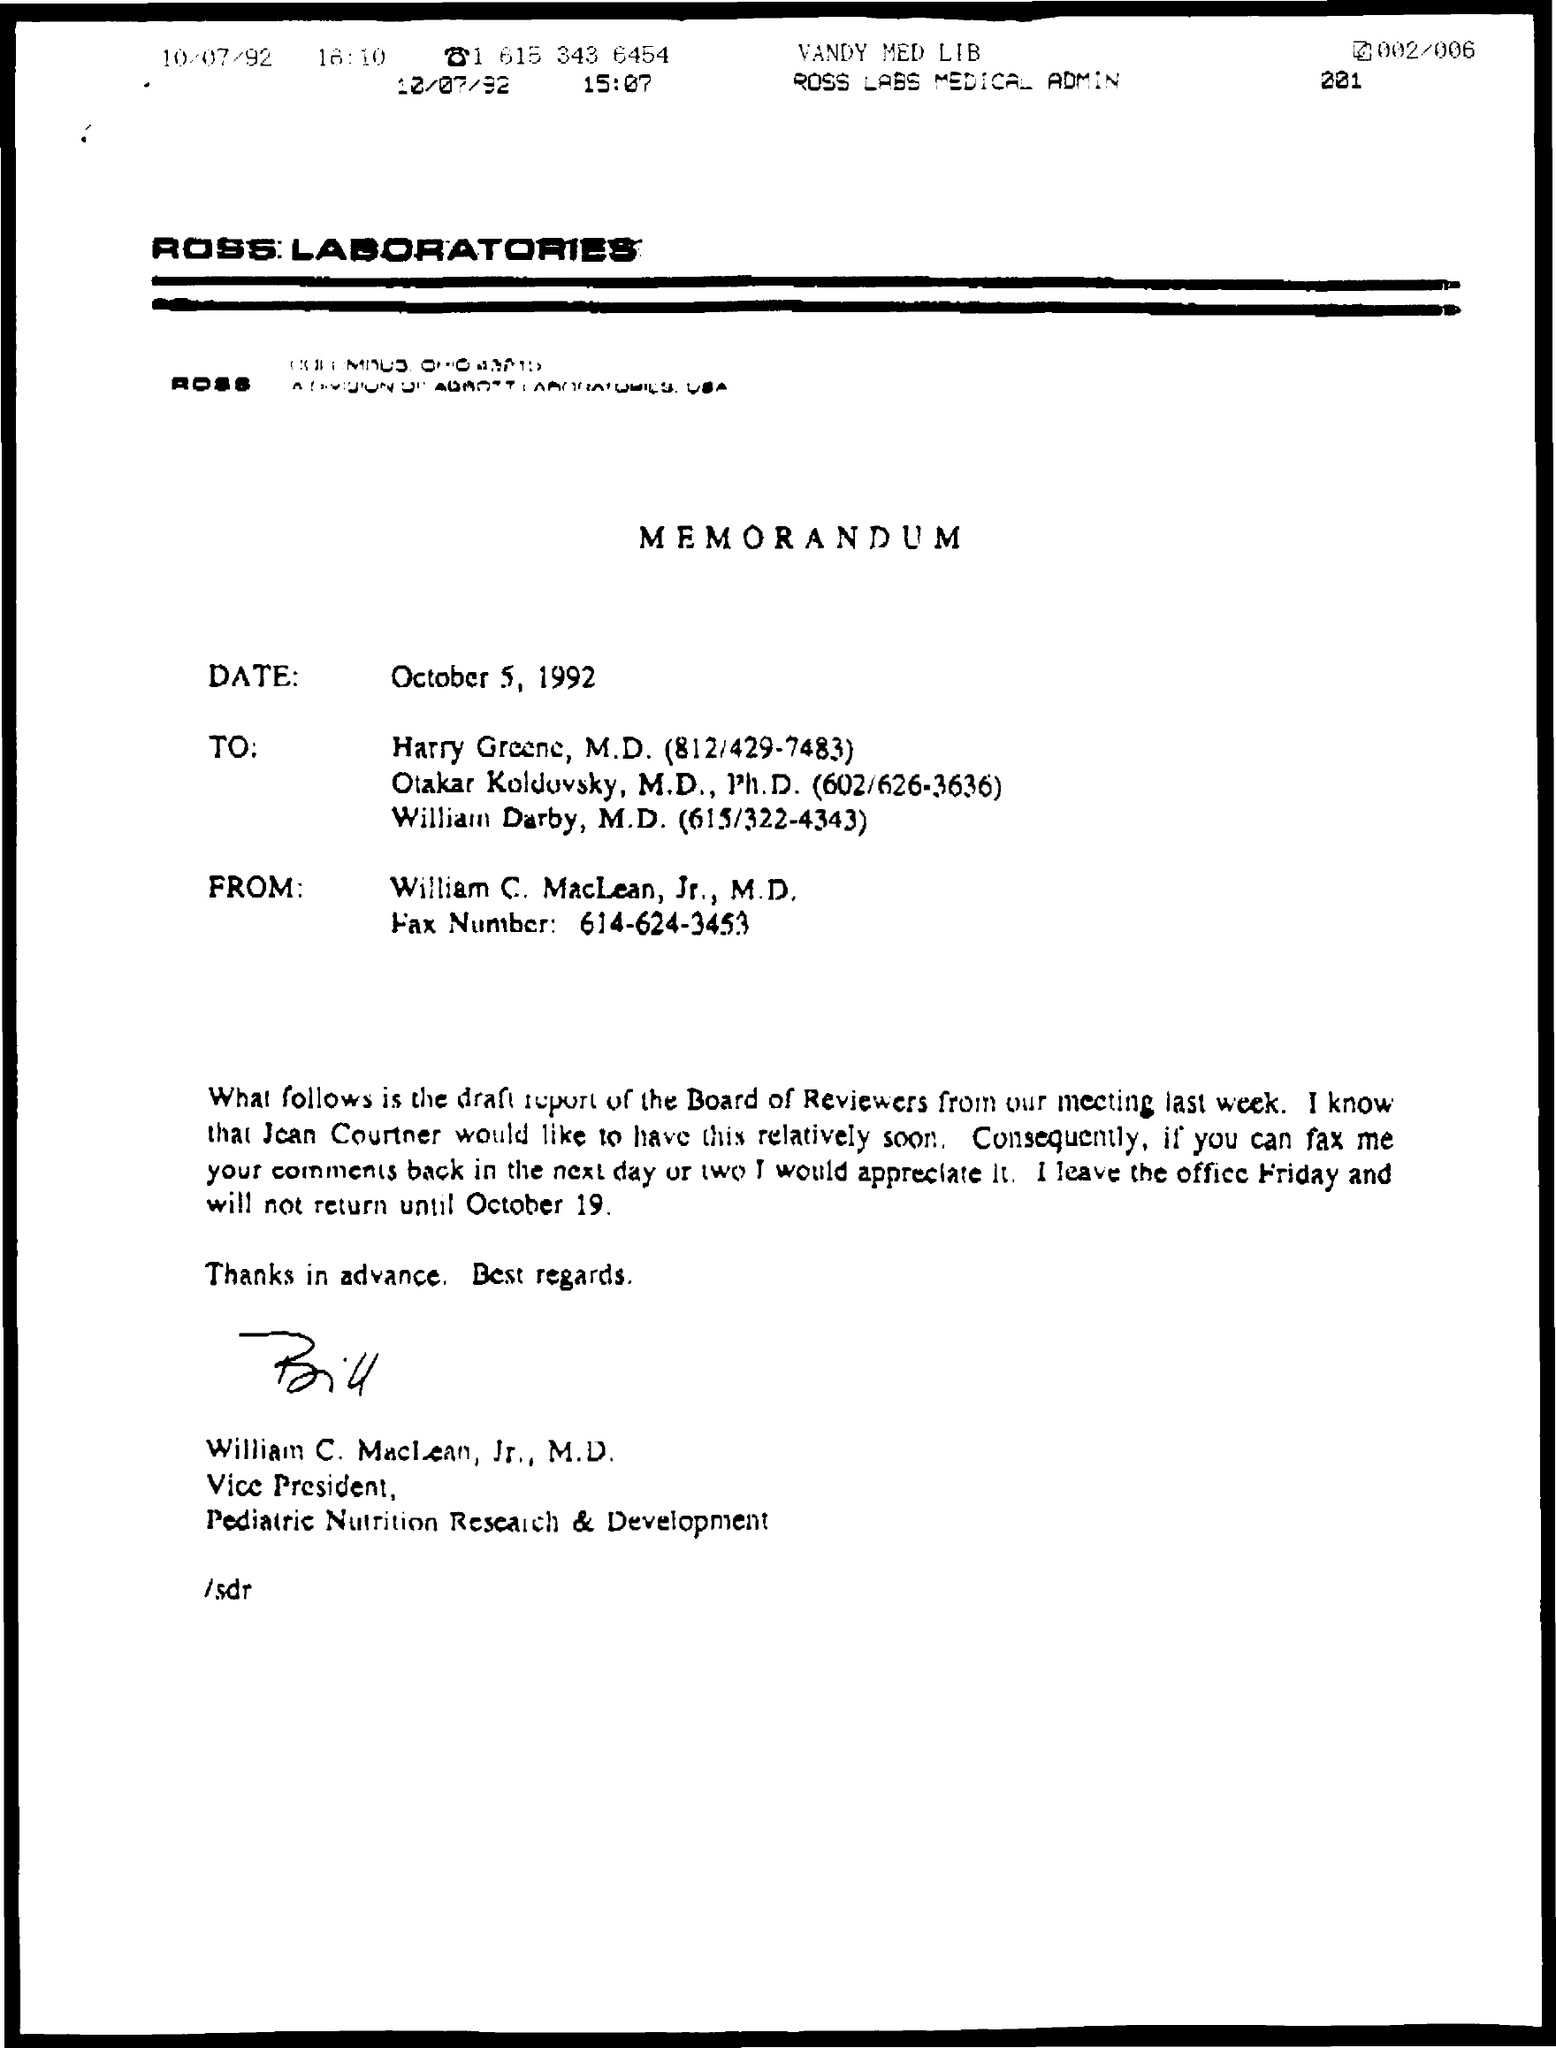What is the designation of william c. maclean as mentioned in the given letter ?
Your response must be concise. Vice President. What is the name of the laboratories mentioned in the given page ?
Your response must be concise. Ross laboratories. 